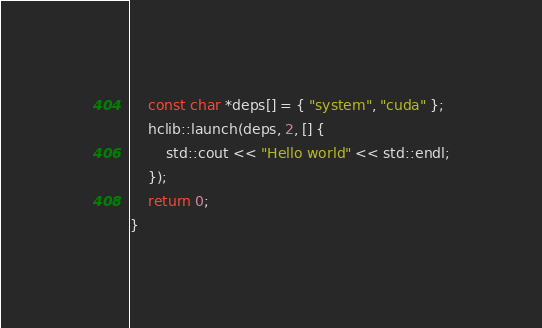<code> <loc_0><loc_0><loc_500><loc_500><_Cuda_>    const char *deps[] = { "system", "cuda" };
    hclib::launch(deps, 2, [] {
        std::cout << "Hello world" << std::endl;
    });
    return 0;
}
</code> 